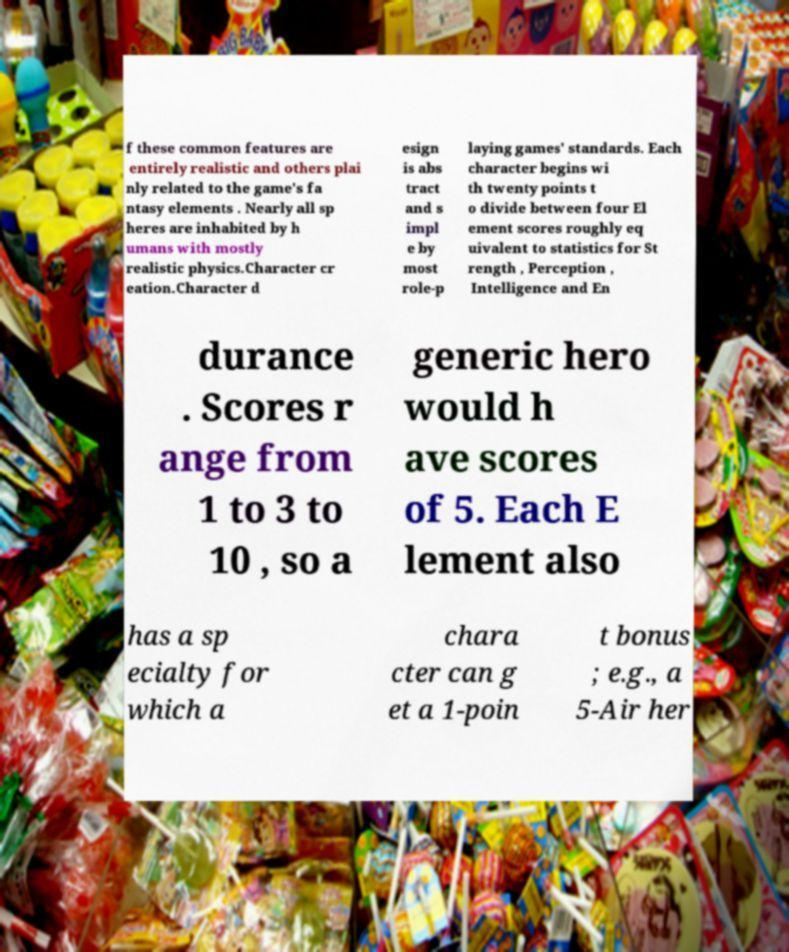Can you accurately transcribe the text from the provided image for me? f these common features are entirely realistic and others plai nly related to the game's fa ntasy elements . Nearly all sp heres are inhabited by h umans with mostly realistic physics.Character cr eation.Character d esign is abs tract and s impl e by most role-p laying games' standards. Each character begins wi th twenty points t o divide between four El ement scores roughly eq uivalent to statistics for St rength , Perception , Intelligence and En durance . Scores r ange from 1 to 3 to 10 , so a generic hero would h ave scores of 5. Each E lement also has a sp ecialty for which a chara cter can g et a 1-poin t bonus ; e.g., a 5-Air her 